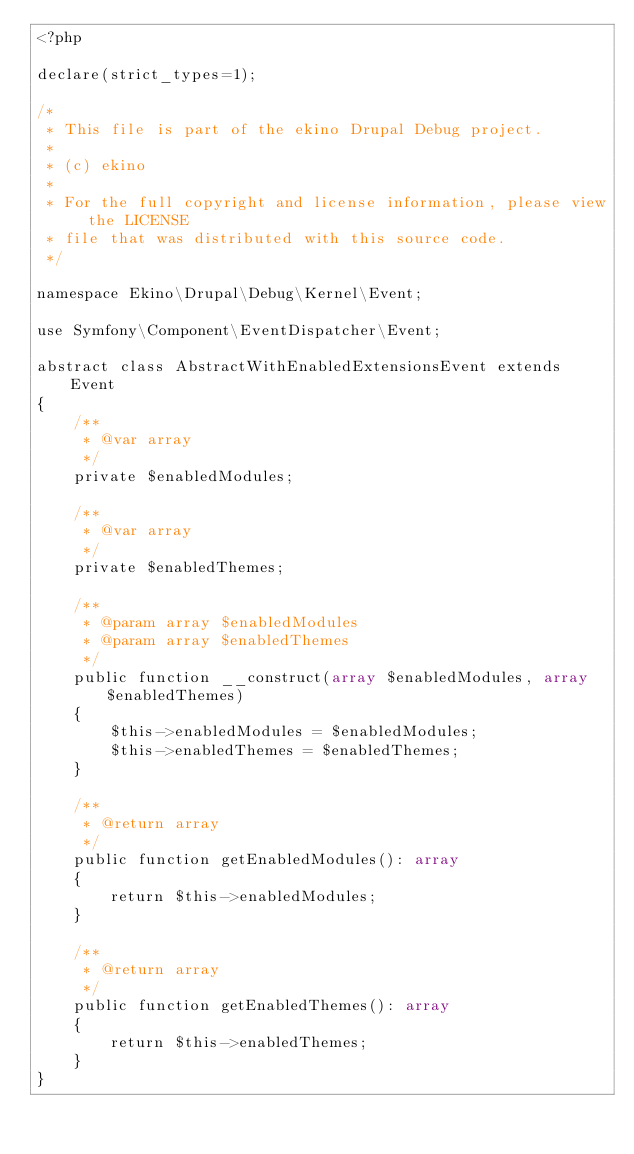<code> <loc_0><loc_0><loc_500><loc_500><_PHP_><?php

declare(strict_types=1);

/*
 * This file is part of the ekino Drupal Debug project.
 *
 * (c) ekino
 *
 * For the full copyright and license information, please view the LICENSE
 * file that was distributed with this source code.
 */

namespace Ekino\Drupal\Debug\Kernel\Event;

use Symfony\Component\EventDispatcher\Event;

abstract class AbstractWithEnabledExtensionsEvent extends Event
{
    /**
     * @var array
     */
    private $enabledModules;

    /**
     * @var array
     */
    private $enabledThemes;

    /**
     * @param array $enabledModules
     * @param array $enabledThemes
     */
    public function __construct(array $enabledModules, array $enabledThemes)
    {
        $this->enabledModules = $enabledModules;
        $this->enabledThemes = $enabledThemes;
    }

    /**
     * @return array
     */
    public function getEnabledModules(): array
    {
        return $this->enabledModules;
    }

    /**
     * @return array
     */
    public function getEnabledThemes(): array
    {
        return $this->enabledThemes;
    }
}
</code> 